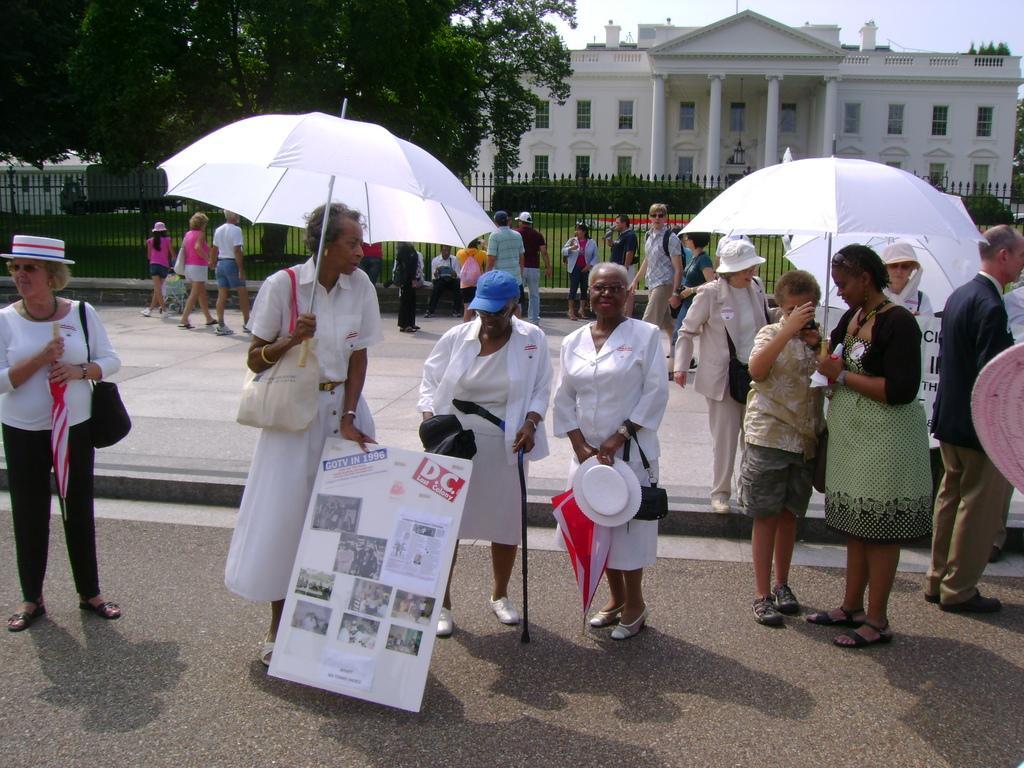Can you describe this image briefly? In this image I can see few people standing on road and one woman holding a board and few people are holding umbrellas and in the background I can see grill at the top of the image I can see a tree and a building. 